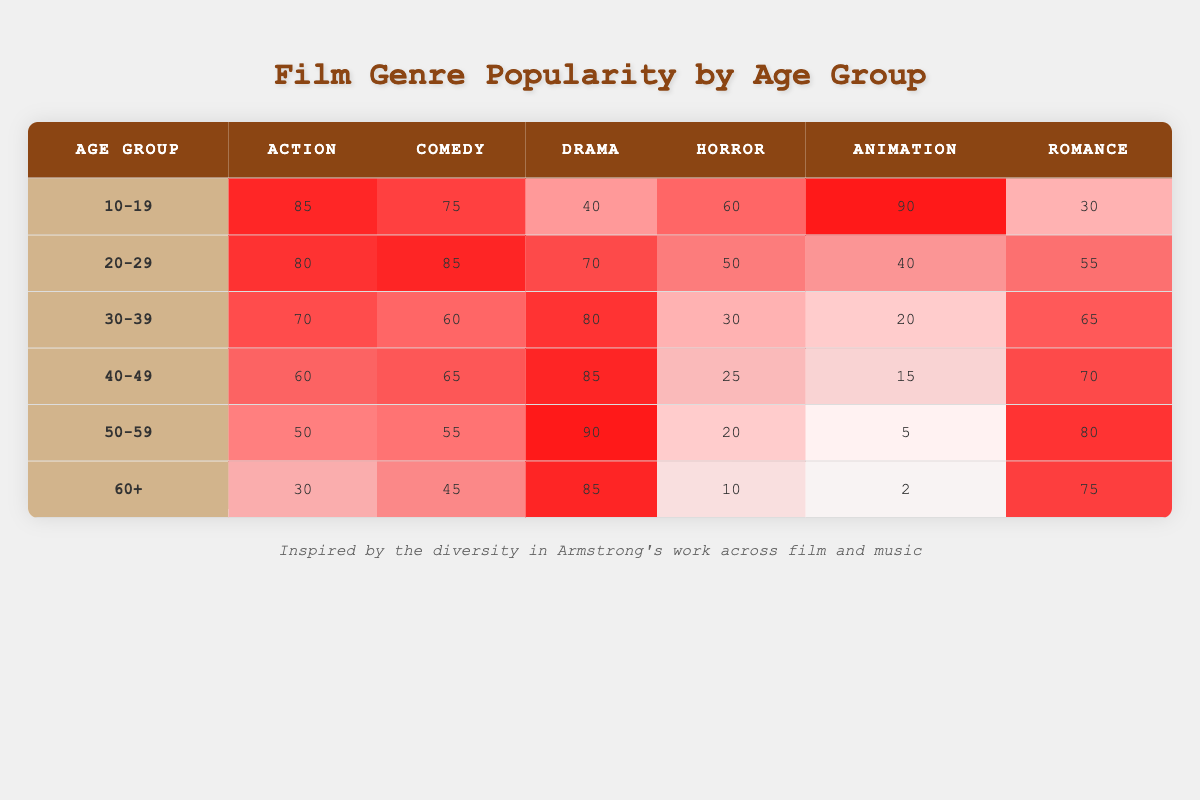What is the most popular film genre among the 10-19 age group? Referring to the table, the highest number (90) in the 10-19 age group is for Animation.
Answer: Animation Which age group has the highest popularity of Horror films? The Age Group 10-19 has a popularity score of 60 for Horror, while the highest scores for other age groups are lower (50 for 20-29, 30 for 30-39, 25 for 40-49, 20 for 50-59, and 10 for 60+). Thus, 10-19 has the highest popularity for Horror.
Answer: 10-19 What is the average popularity score for Comedy across all age groups? The popularity scores for Comedy are 75, 85, 60, 65, 55, and 45. Adding these gives 75 + 85 + 60 + 65 + 55 + 45 = 385. Dividing by 6 (the number of age groups) results in an average of approximately 64.17.
Answer: 64.17 Is Drama more popular than Action in the 40-49 age group? For the 40-49 age group, Drama has a score of 85 while Action has a score of 60. Since 85 is greater than 60, Drama is indeed more popular than Action in this age group.
Answer: Yes In which age group does Animation show the least popularity? The table shows Animation scores of 90, 40, 20, 15, 5, and 2 across different age groups. The lowest score is 2, which corresponds to the 60+ age group.
Answer: 60+ What is the difference in popularity of Action films between the 20-29 and 50-59 age groups? The score for Action in the 20-29 age group is 80, and in the 50-59 age group, it is 50. The difference is calculated as 80 - 50 = 30.
Answer: 30 Does the 30-39 age group have a higher total score in Drama compared to Animation? The score for Drama in the 30-39 age group is 80, while for Animation it is 20. Since 80 is greater than 20, the 30-39 age group indeed has a higher total score in Drama than in Animation.
Answer: Yes Which genre is consistently popular across all age groups? Examining all age groups, Romance has scores of 30, 55, 65, 70, 80, and 75. All are moderately high. There's no genre with higher values consistently across all. This means the genre that appears often but not consistently at high values is Romance.
Answer: None 